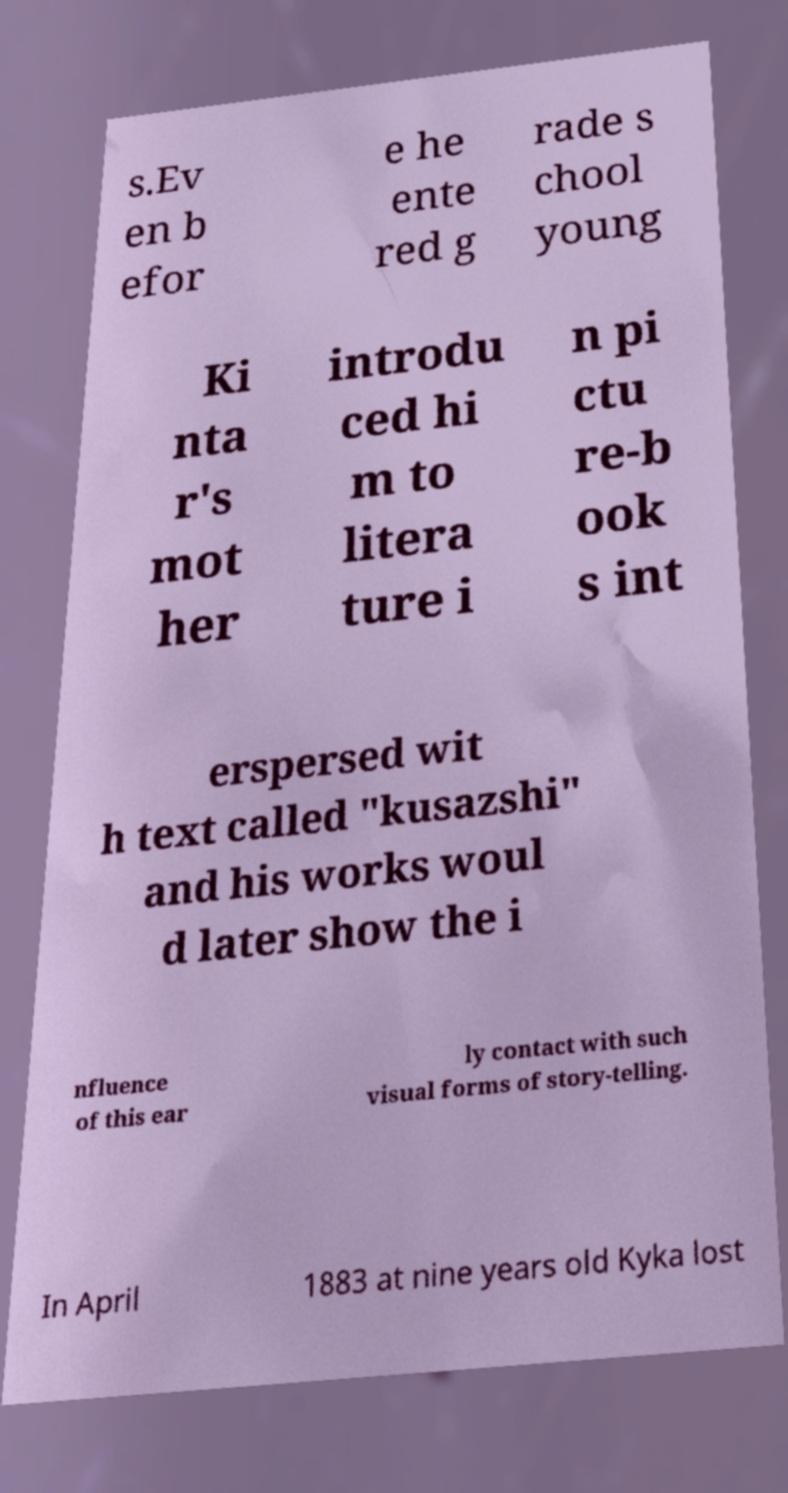Could you extract and type out the text from this image? s.Ev en b efor e he ente red g rade s chool young Ki nta r's mot her introdu ced hi m to litera ture i n pi ctu re-b ook s int erspersed wit h text called "kusazshi" and his works woul d later show the i nfluence of this ear ly contact with such visual forms of story-telling. In April 1883 at nine years old Kyka lost 